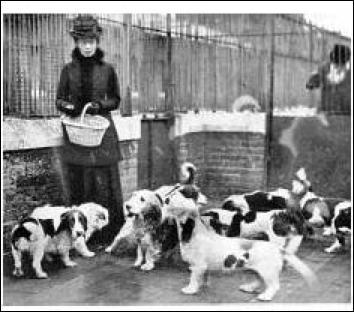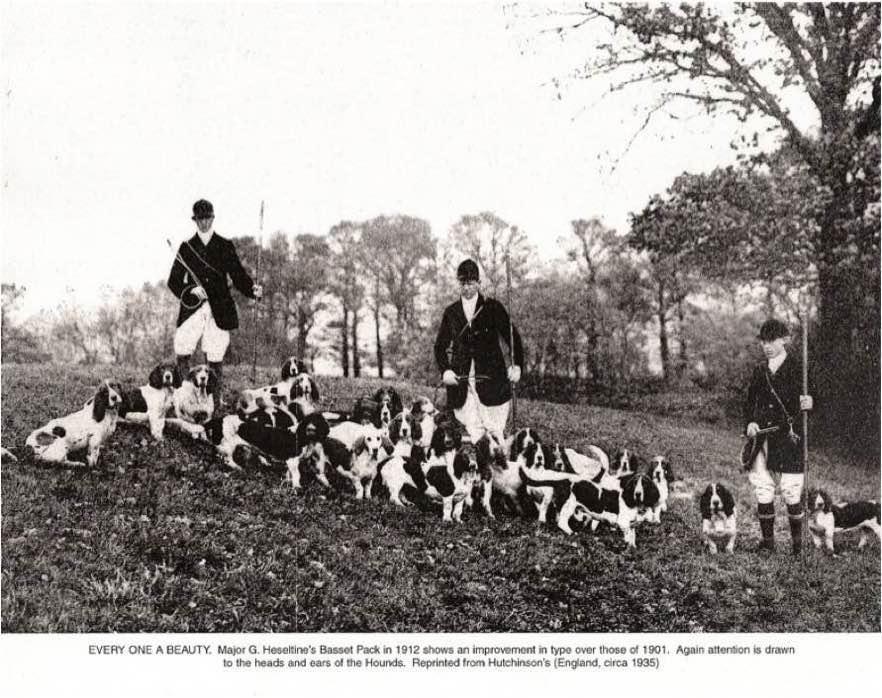The first image is the image on the left, the second image is the image on the right. Analyze the images presented: Is the assertion "There are fewer than three people wrangling a pack of dogs." valid? Answer yes or no. No. 